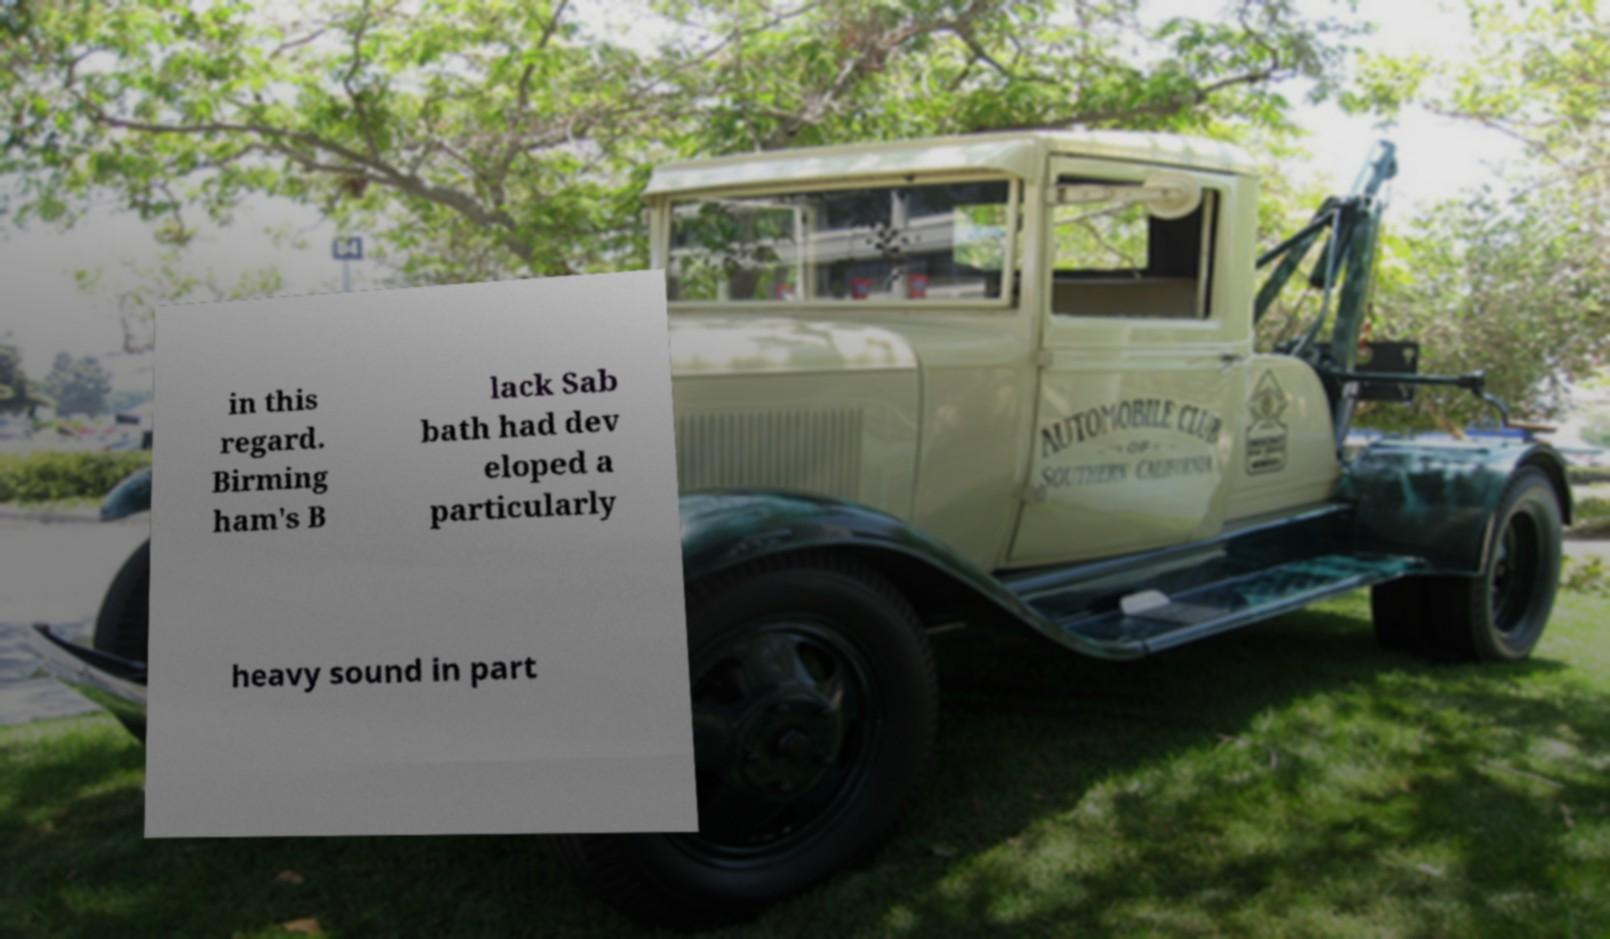Could you extract and type out the text from this image? in this regard. Birming ham's B lack Sab bath had dev eloped a particularly heavy sound in part 